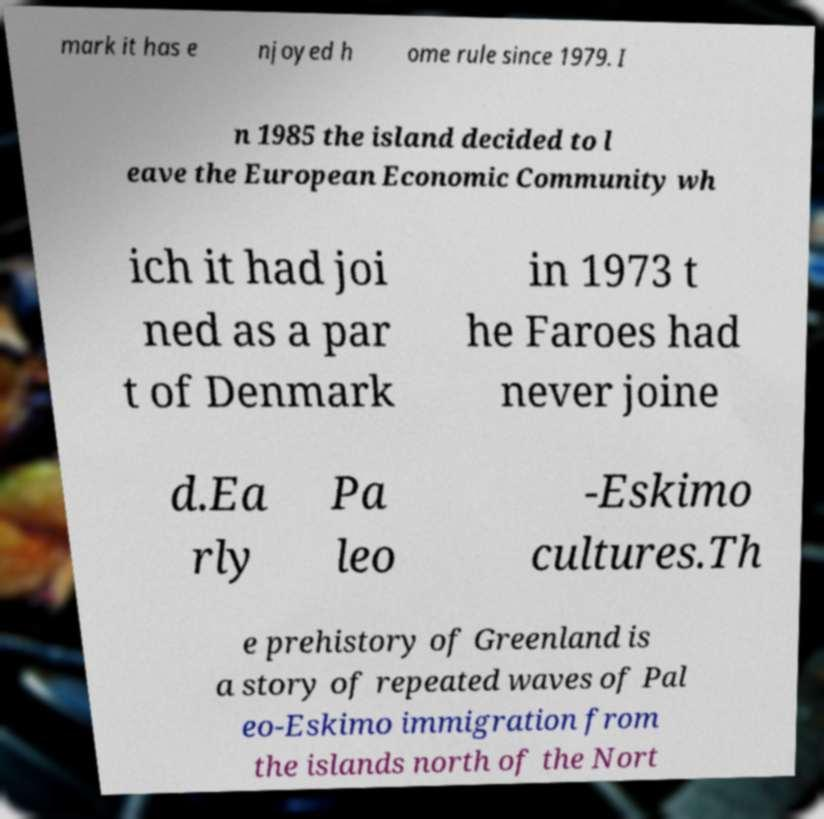Could you extract and type out the text from this image? mark it has e njoyed h ome rule since 1979. I n 1985 the island decided to l eave the European Economic Community wh ich it had joi ned as a par t of Denmark in 1973 t he Faroes had never joine d.Ea rly Pa leo -Eskimo cultures.Th e prehistory of Greenland is a story of repeated waves of Pal eo-Eskimo immigration from the islands north of the Nort 